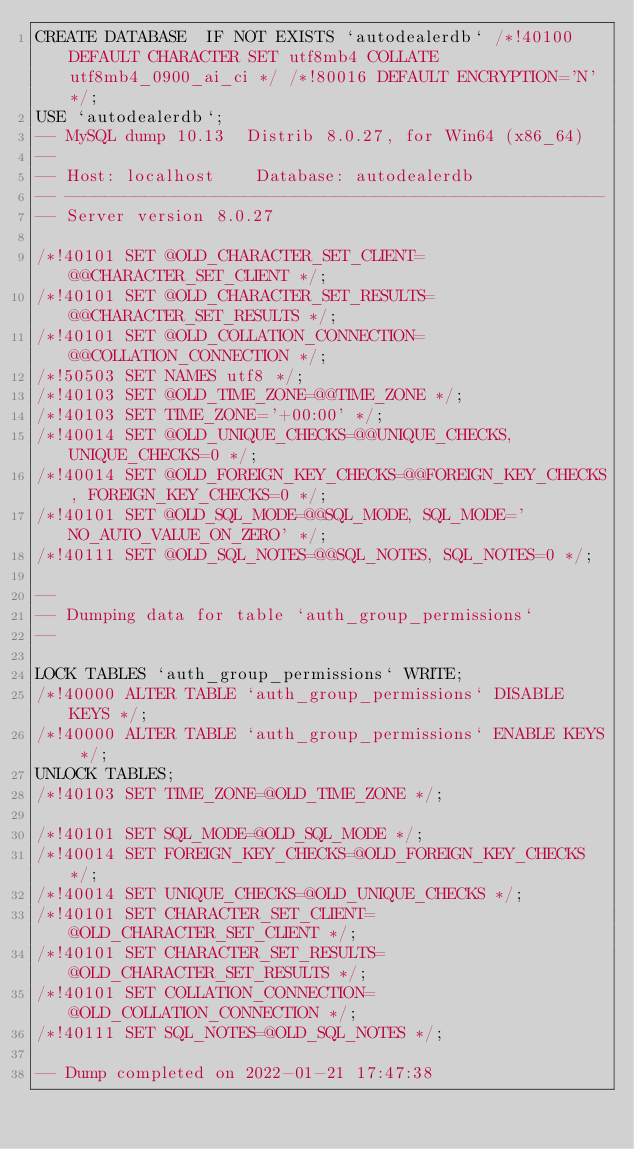Convert code to text. <code><loc_0><loc_0><loc_500><loc_500><_SQL_>CREATE DATABASE  IF NOT EXISTS `autodealerdb` /*!40100 DEFAULT CHARACTER SET utf8mb4 COLLATE utf8mb4_0900_ai_ci */ /*!80016 DEFAULT ENCRYPTION='N' */;
USE `autodealerdb`;
-- MySQL dump 10.13  Distrib 8.0.27, for Win64 (x86_64)
--
-- Host: localhost    Database: autodealerdb
-- ------------------------------------------------------
-- Server version	8.0.27

/*!40101 SET @OLD_CHARACTER_SET_CLIENT=@@CHARACTER_SET_CLIENT */;
/*!40101 SET @OLD_CHARACTER_SET_RESULTS=@@CHARACTER_SET_RESULTS */;
/*!40101 SET @OLD_COLLATION_CONNECTION=@@COLLATION_CONNECTION */;
/*!50503 SET NAMES utf8 */;
/*!40103 SET @OLD_TIME_ZONE=@@TIME_ZONE */;
/*!40103 SET TIME_ZONE='+00:00' */;
/*!40014 SET @OLD_UNIQUE_CHECKS=@@UNIQUE_CHECKS, UNIQUE_CHECKS=0 */;
/*!40014 SET @OLD_FOREIGN_KEY_CHECKS=@@FOREIGN_KEY_CHECKS, FOREIGN_KEY_CHECKS=0 */;
/*!40101 SET @OLD_SQL_MODE=@@SQL_MODE, SQL_MODE='NO_AUTO_VALUE_ON_ZERO' */;
/*!40111 SET @OLD_SQL_NOTES=@@SQL_NOTES, SQL_NOTES=0 */;

--
-- Dumping data for table `auth_group_permissions`
--

LOCK TABLES `auth_group_permissions` WRITE;
/*!40000 ALTER TABLE `auth_group_permissions` DISABLE KEYS */;
/*!40000 ALTER TABLE `auth_group_permissions` ENABLE KEYS */;
UNLOCK TABLES;
/*!40103 SET TIME_ZONE=@OLD_TIME_ZONE */;

/*!40101 SET SQL_MODE=@OLD_SQL_MODE */;
/*!40014 SET FOREIGN_KEY_CHECKS=@OLD_FOREIGN_KEY_CHECKS */;
/*!40014 SET UNIQUE_CHECKS=@OLD_UNIQUE_CHECKS */;
/*!40101 SET CHARACTER_SET_CLIENT=@OLD_CHARACTER_SET_CLIENT */;
/*!40101 SET CHARACTER_SET_RESULTS=@OLD_CHARACTER_SET_RESULTS */;
/*!40101 SET COLLATION_CONNECTION=@OLD_COLLATION_CONNECTION */;
/*!40111 SET SQL_NOTES=@OLD_SQL_NOTES */;

-- Dump completed on 2022-01-21 17:47:38
</code> 